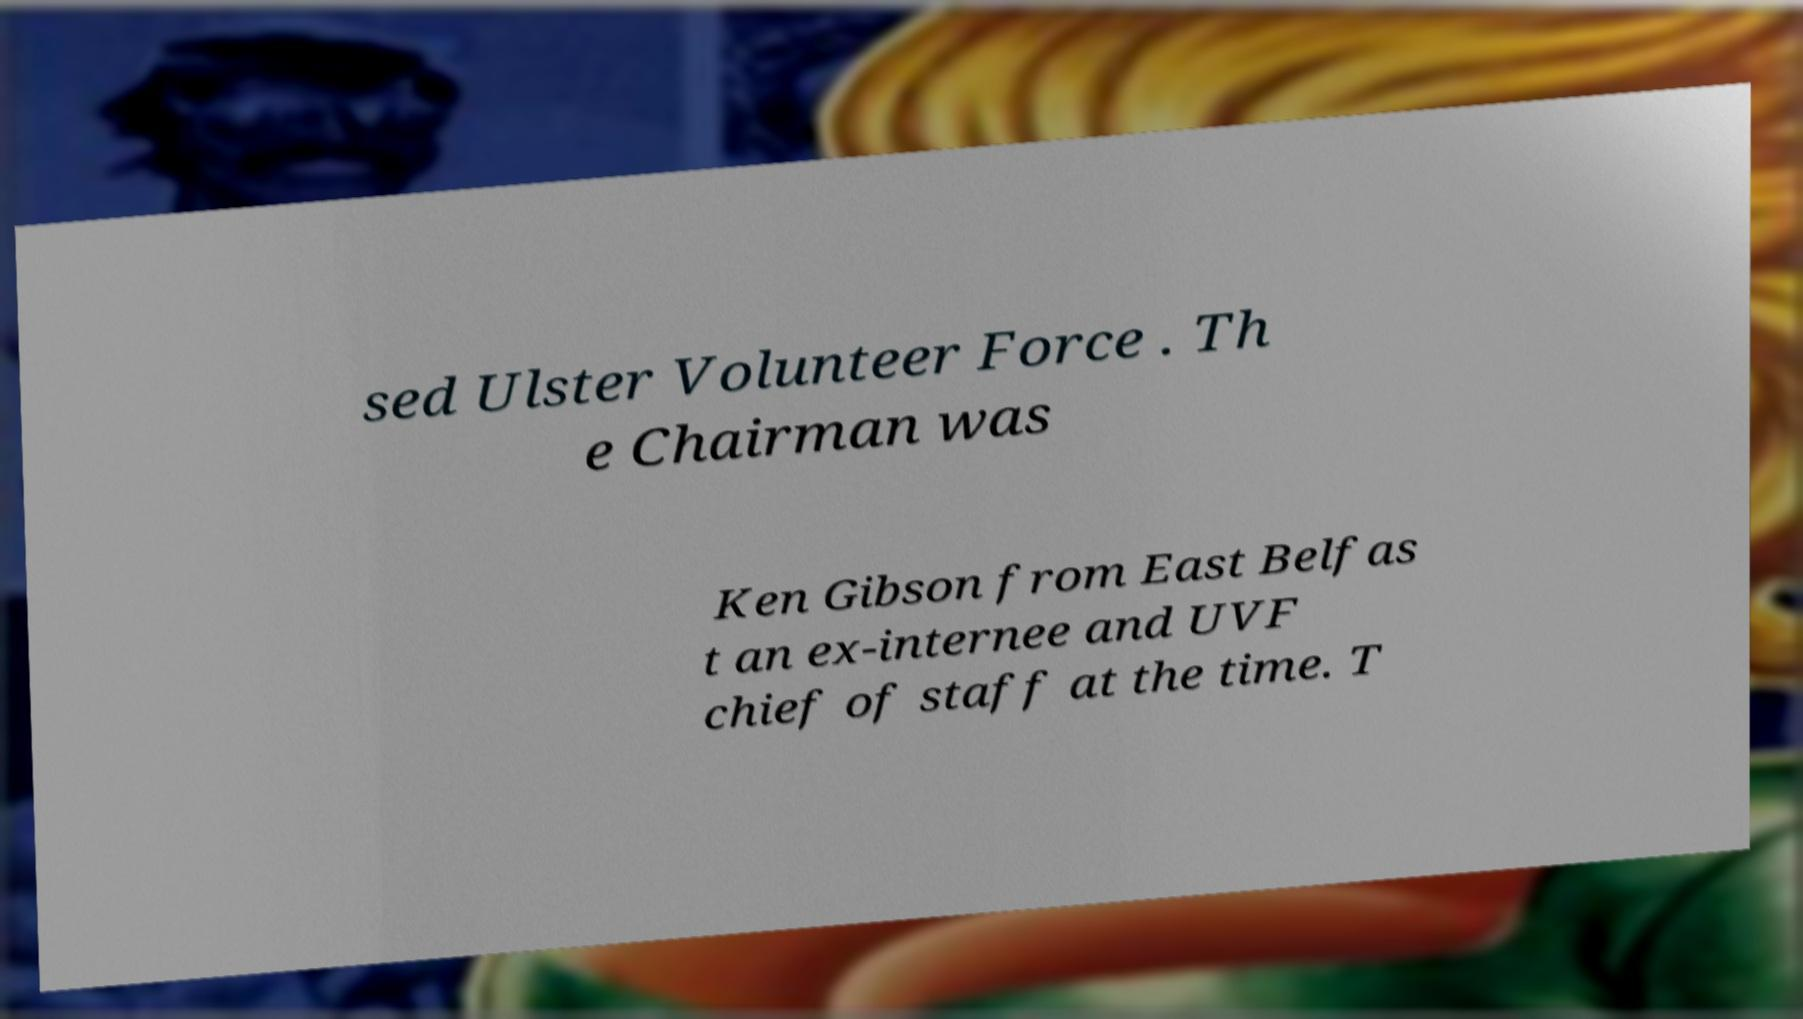Could you assist in decoding the text presented in this image and type it out clearly? sed Ulster Volunteer Force . Th e Chairman was Ken Gibson from East Belfas t an ex-internee and UVF chief of staff at the time. T 